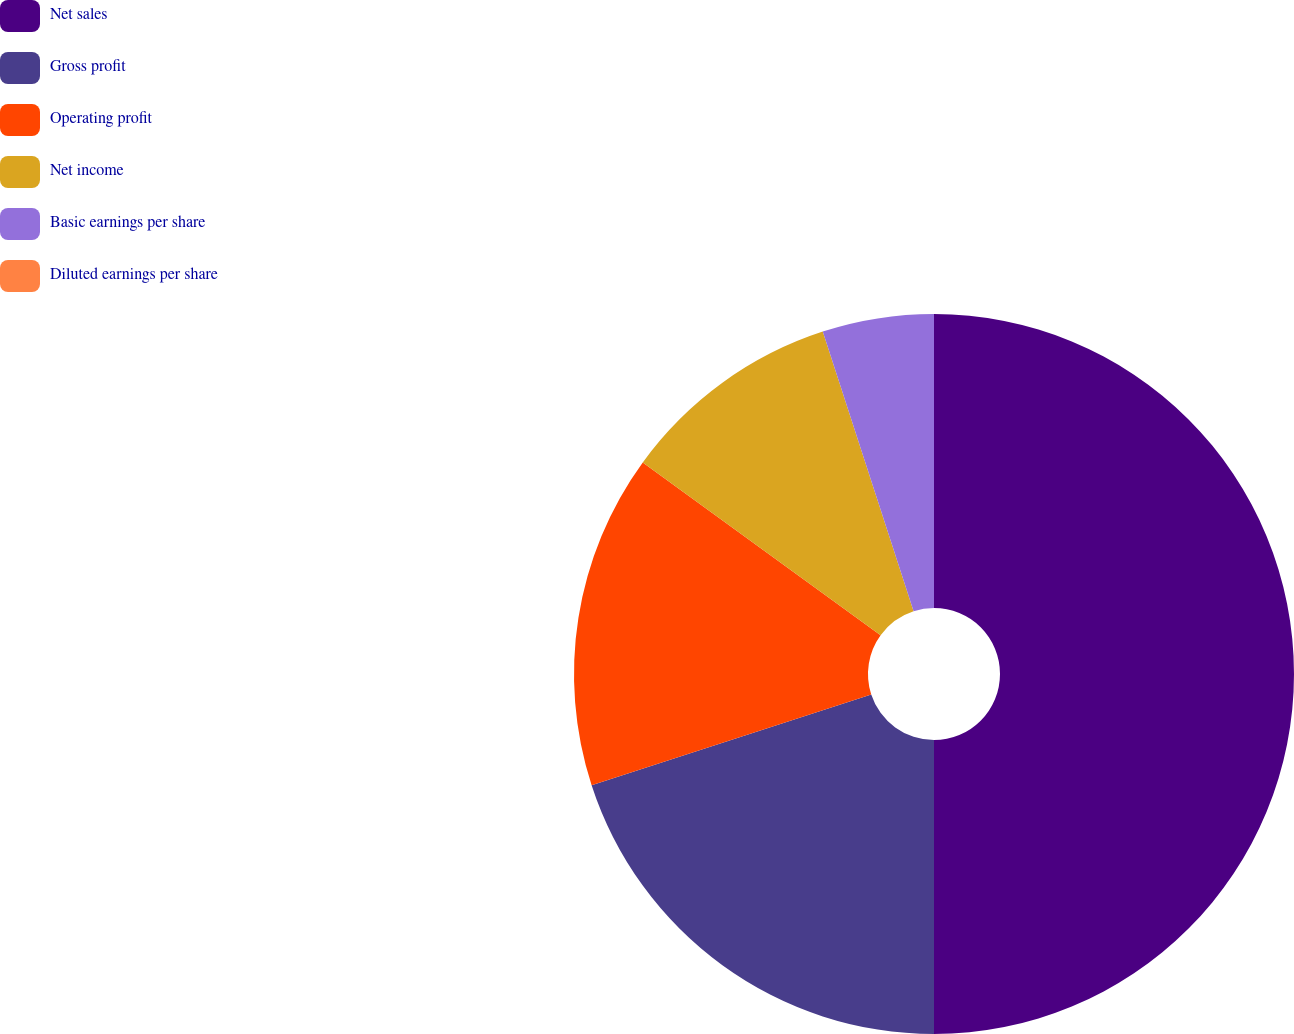Convert chart to OTSL. <chart><loc_0><loc_0><loc_500><loc_500><pie_chart><fcel>Net sales<fcel>Gross profit<fcel>Operating profit<fcel>Net income<fcel>Basic earnings per share<fcel>Diluted earnings per share<nl><fcel>50.0%<fcel>20.0%<fcel>15.0%<fcel>10.0%<fcel>5.0%<fcel>0.0%<nl></chart> 